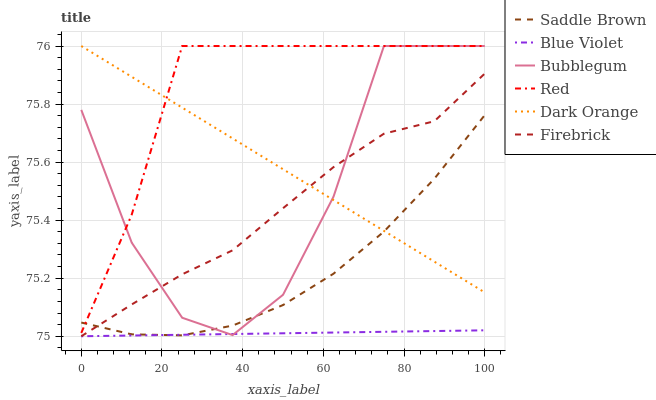Does Blue Violet have the minimum area under the curve?
Answer yes or no. Yes. Does Red have the maximum area under the curve?
Answer yes or no. Yes. Does Firebrick have the minimum area under the curve?
Answer yes or no. No. Does Firebrick have the maximum area under the curve?
Answer yes or no. No. Is Dark Orange the smoothest?
Answer yes or no. Yes. Is Bubblegum the roughest?
Answer yes or no. Yes. Is Firebrick the smoothest?
Answer yes or no. No. Is Firebrick the roughest?
Answer yes or no. No. Does Firebrick have the lowest value?
Answer yes or no. Yes. Does Bubblegum have the lowest value?
Answer yes or no. No. Does Red have the highest value?
Answer yes or no. Yes. Does Firebrick have the highest value?
Answer yes or no. No. Is Firebrick less than Red?
Answer yes or no. Yes. Is Dark Orange greater than Blue Violet?
Answer yes or no. Yes. Does Firebrick intersect Bubblegum?
Answer yes or no. Yes. Is Firebrick less than Bubblegum?
Answer yes or no. No. Is Firebrick greater than Bubblegum?
Answer yes or no. No. Does Firebrick intersect Red?
Answer yes or no. No. 